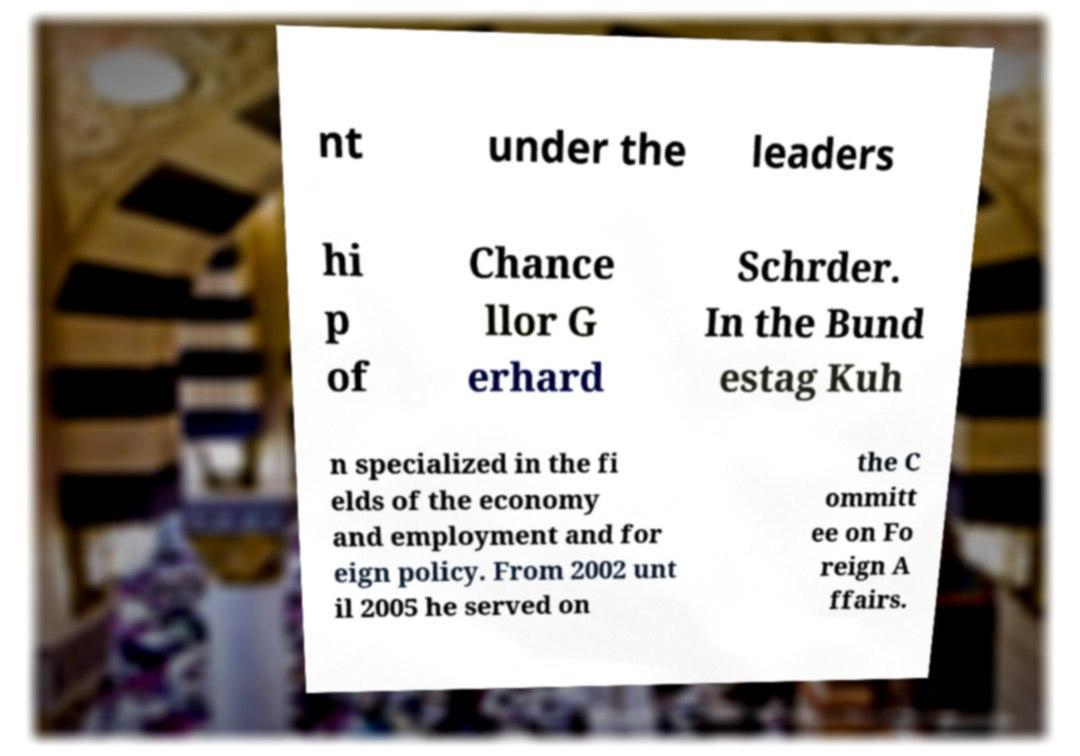For documentation purposes, I need the text within this image transcribed. Could you provide that? nt under the leaders hi p of Chance llor G erhard Schrder. In the Bund estag Kuh n specialized in the fi elds of the economy and employment and for eign policy. From 2002 unt il 2005 he served on the C ommitt ee on Fo reign A ffairs. 